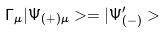Convert formula to latex. <formula><loc_0><loc_0><loc_500><loc_500>\Gamma _ { \mu } | \Psi _ { ( + ) \mu } > = | \Psi ^ { \prime } _ { ( - ) } ></formula> 